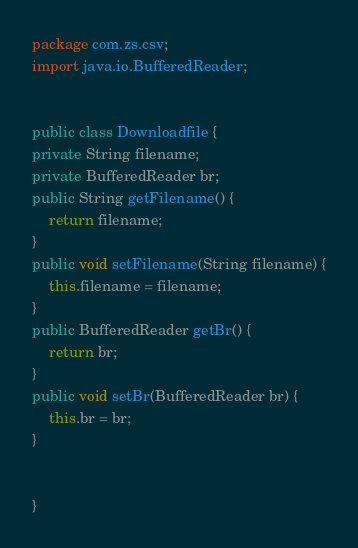Convert code to text. <code><loc_0><loc_0><loc_500><loc_500><_Java_>package com.zs.csv;
import java.io.BufferedReader;


public class Downloadfile {
private String filename;
private BufferedReader br;
public String getFilename() {
	return filename;
}
public void setFilename(String filename) {
	this.filename = filename;
}
public BufferedReader getBr() {
	return br;
}
public void setBr(BufferedReader br) {
	this.br = br;
}


}
</code> 